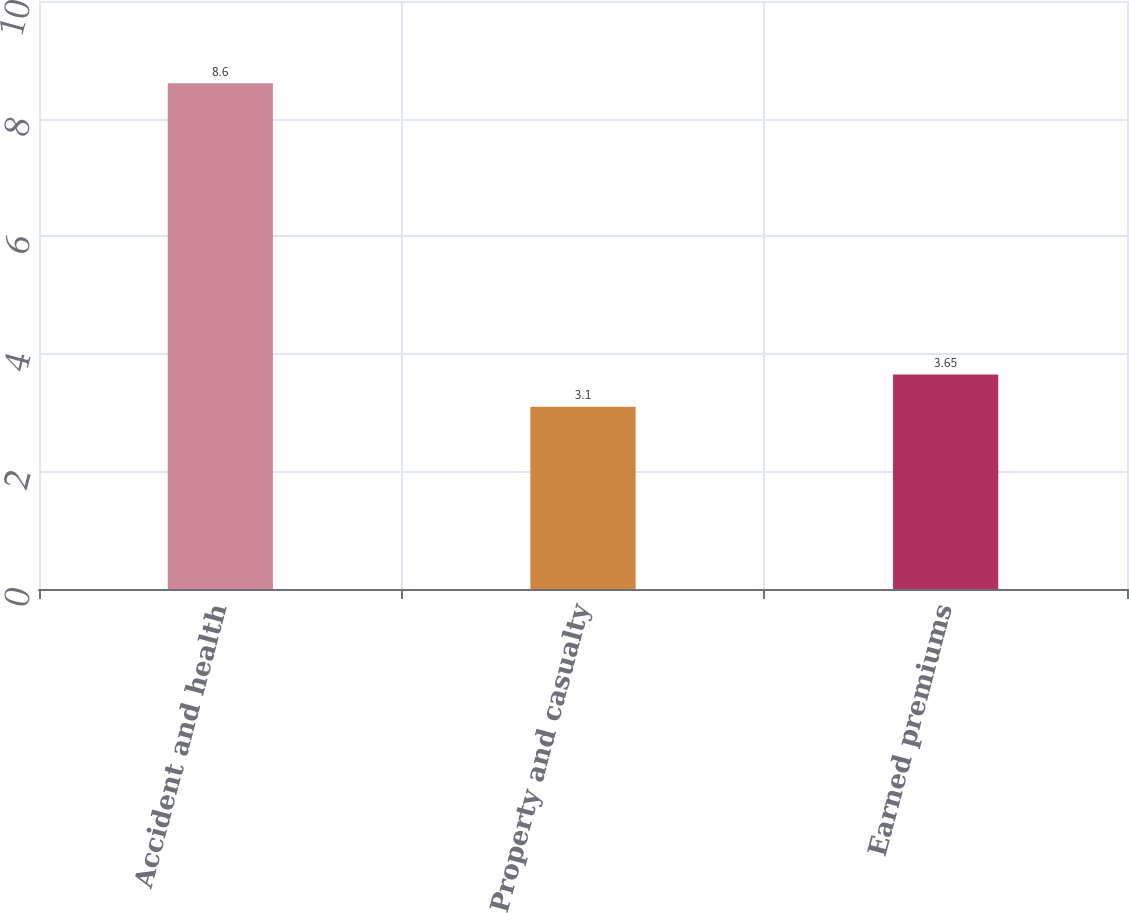Convert chart to OTSL. <chart><loc_0><loc_0><loc_500><loc_500><bar_chart><fcel>Accident and health<fcel>Property and casualty<fcel>Earned premiums<nl><fcel>8.6<fcel>3.1<fcel>3.65<nl></chart> 